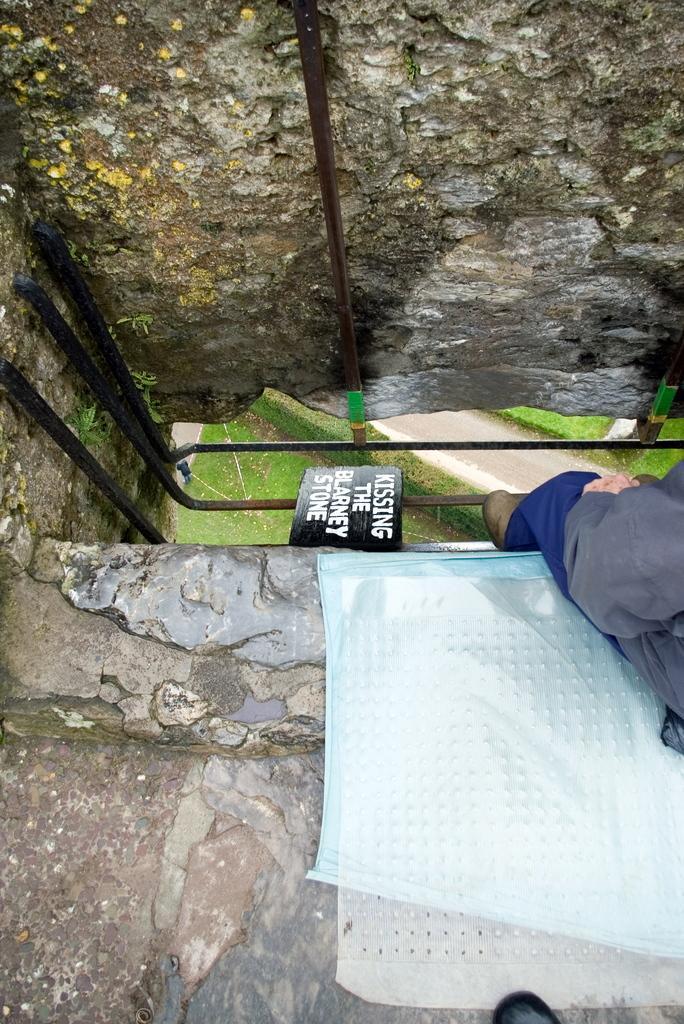Please provide a concise description of this image. In this image we can see a person sitting on the surface, we can also see some metal poles and a sign board with some text on it. In the background we can see grass, a group of plants and pathway. 